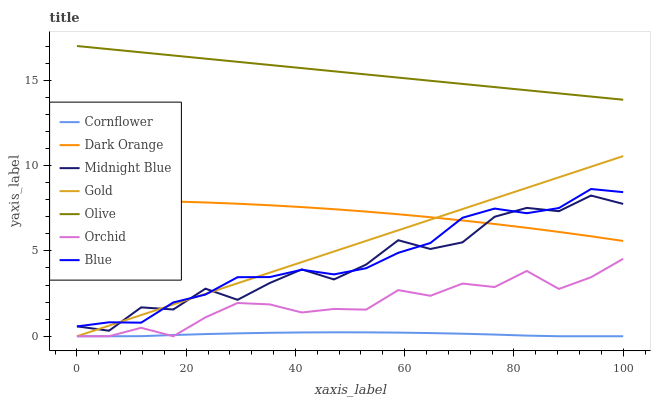Does Cornflower have the minimum area under the curve?
Answer yes or no. Yes. Does Olive have the maximum area under the curve?
Answer yes or no. Yes. Does Midnight Blue have the minimum area under the curve?
Answer yes or no. No. Does Midnight Blue have the maximum area under the curve?
Answer yes or no. No. Is Gold the smoothest?
Answer yes or no. Yes. Is Midnight Blue the roughest?
Answer yes or no. Yes. Is Cornflower the smoothest?
Answer yes or no. No. Is Cornflower the roughest?
Answer yes or no. No. Does Cornflower have the lowest value?
Answer yes or no. Yes. Does Midnight Blue have the lowest value?
Answer yes or no. No. Does Olive have the highest value?
Answer yes or no. Yes. Does Midnight Blue have the highest value?
Answer yes or no. No. Is Orchid less than Olive?
Answer yes or no. Yes. Is Olive greater than Orchid?
Answer yes or no. Yes. Does Gold intersect Orchid?
Answer yes or no. Yes. Is Gold less than Orchid?
Answer yes or no. No. Is Gold greater than Orchid?
Answer yes or no. No. Does Orchid intersect Olive?
Answer yes or no. No. 